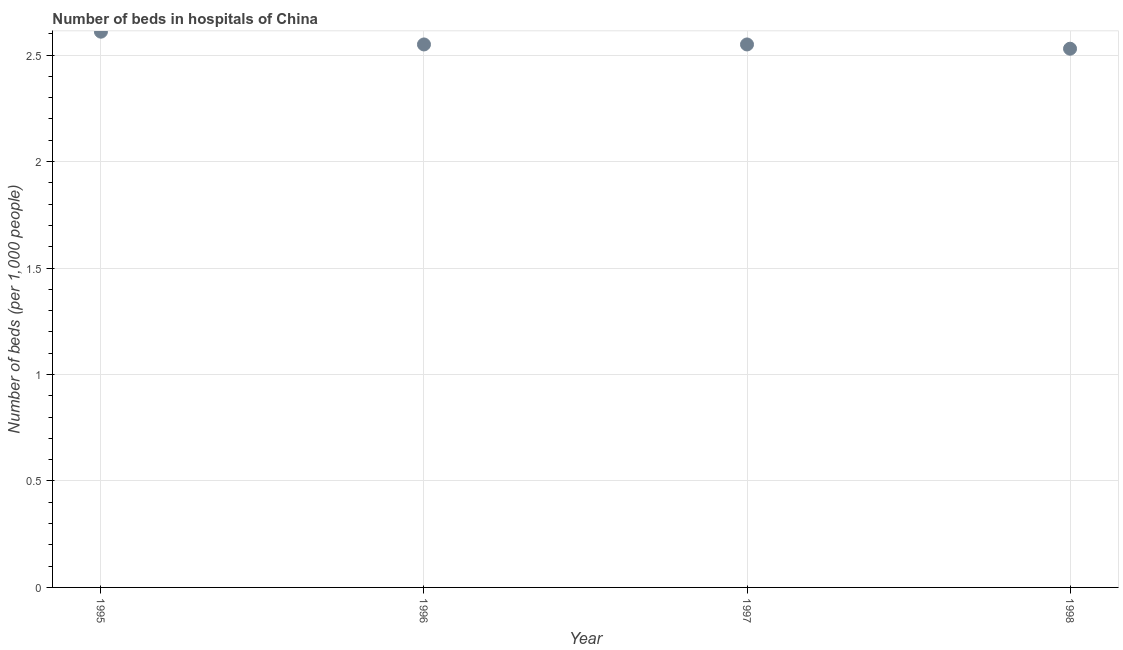What is the number of hospital beds in 1998?
Provide a short and direct response. 2.53. Across all years, what is the maximum number of hospital beds?
Offer a very short reply. 2.61. Across all years, what is the minimum number of hospital beds?
Provide a short and direct response. 2.53. What is the sum of the number of hospital beds?
Your answer should be very brief. 10.24. What is the difference between the number of hospital beds in 1995 and 1997?
Keep it short and to the point. 0.06. What is the average number of hospital beds per year?
Give a very brief answer. 2.56. What is the median number of hospital beds?
Your answer should be compact. 2.55. What is the ratio of the number of hospital beds in 1995 to that in 1998?
Your answer should be very brief. 1.03. What is the difference between the highest and the second highest number of hospital beds?
Provide a succinct answer. 0.06. Is the sum of the number of hospital beds in 1995 and 1996 greater than the maximum number of hospital beds across all years?
Offer a very short reply. Yes. What is the difference between the highest and the lowest number of hospital beds?
Offer a terse response. 0.08. Does the number of hospital beds monotonically increase over the years?
Make the answer very short. No. How many dotlines are there?
Offer a terse response. 1. How many years are there in the graph?
Keep it short and to the point. 4. What is the difference between two consecutive major ticks on the Y-axis?
Ensure brevity in your answer.  0.5. What is the title of the graph?
Your answer should be very brief. Number of beds in hospitals of China. What is the label or title of the X-axis?
Keep it short and to the point. Year. What is the label or title of the Y-axis?
Provide a succinct answer. Number of beds (per 1,0 people). What is the Number of beds (per 1,000 people) in 1995?
Ensure brevity in your answer.  2.61. What is the Number of beds (per 1,000 people) in 1996?
Keep it short and to the point. 2.55. What is the Number of beds (per 1,000 people) in 1997?
Offer a very short reply. 2.55. What is the Number of beds (per 1,000 people) in 1998?
Make the answer very short. 2.53. What is the difference between the Number of beds (per 1,000 people) in 1995 and 1997?
Provide a short and direct response. 0.06. What is the difference between the Number of beds (per 1,000 people) in 1995 and 1998?
Make the answer very short. 0.08. What is the difference between the Number of beds (per 1,000 people) in 1996 and 1998?
Keep it short and to the point. 0.02. What is the difference between the Number of beds (per 1,000 people) in 1997 and 1998?
Your answer should be very brief. 0.02. What is the ratio of the Number of beds (per 1,000 people) in 1995 to that in 1997?
Keep it short and to the point. 1.02. What is the ratio of the Number of beds (per 1,000 people) in 1995 to that in 1998?
Your response must be concise. 1.03. What is the ratio of the Number of beds (per 1,000 people) in 1996 to that in 1998?
Provide a succinct answer. 1.01. 